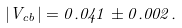Convert formula to latex. <formula><loc_0><loc_0><loc_500><loc_500>| V _ { c b } | = 0 . 0 4 1 \pm 0 . 0 0 2 .</formula> 